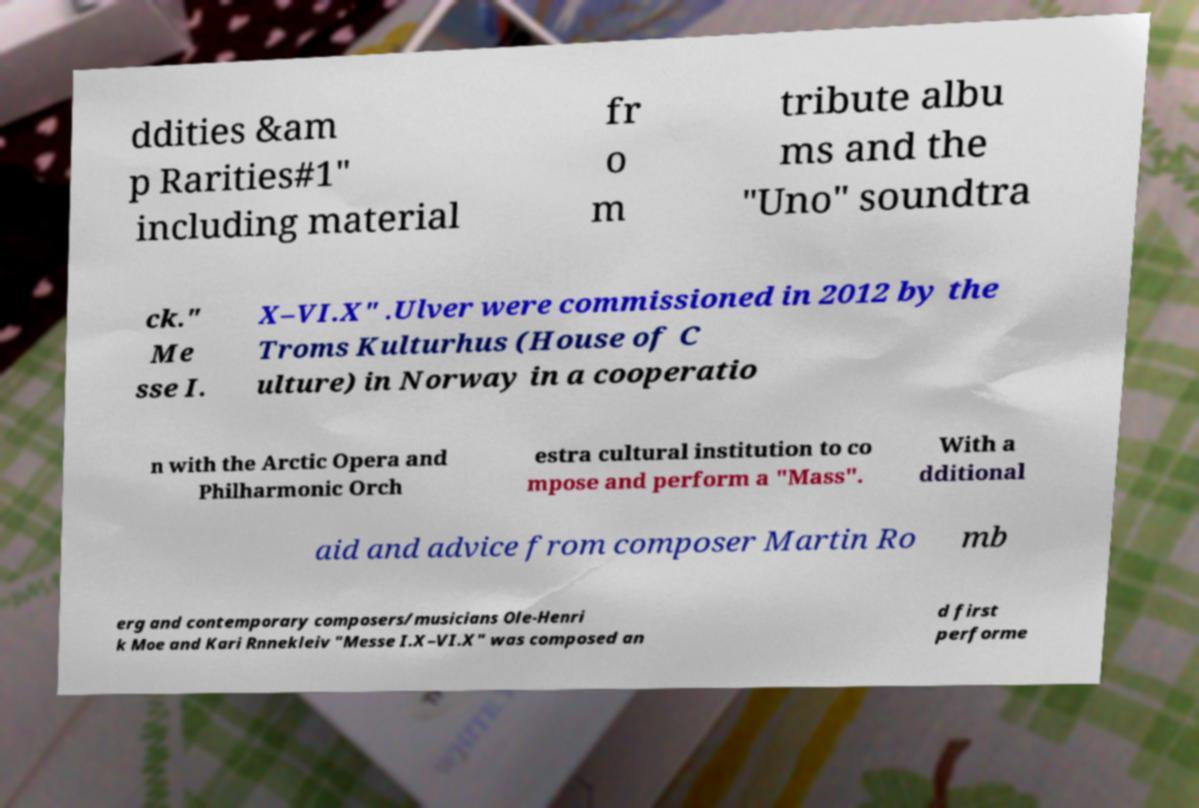For documentation purposes, I need the text within this image transcribed. Could you provide that? ddities &am p Rarities#1" including material fr o m tribute albu ms and the "Uno" soundtra ck." Me sse I. X–VI.X" .Ulver were commissioned in 2012 by the Troms Kulturhus (House of C ulture) in Norway in a cooperatio n with the Arctic Opera and Philharmonic Orch estra cultural institution to co mpose and perform a "Mass". With a dditional aid and advice from composer Martin Ro mb erg and contemporary composers/musicians Ole-Henri k Moe and Kari Rnnekleiv "Messe I.X–VI.X" was composed an d first performe 